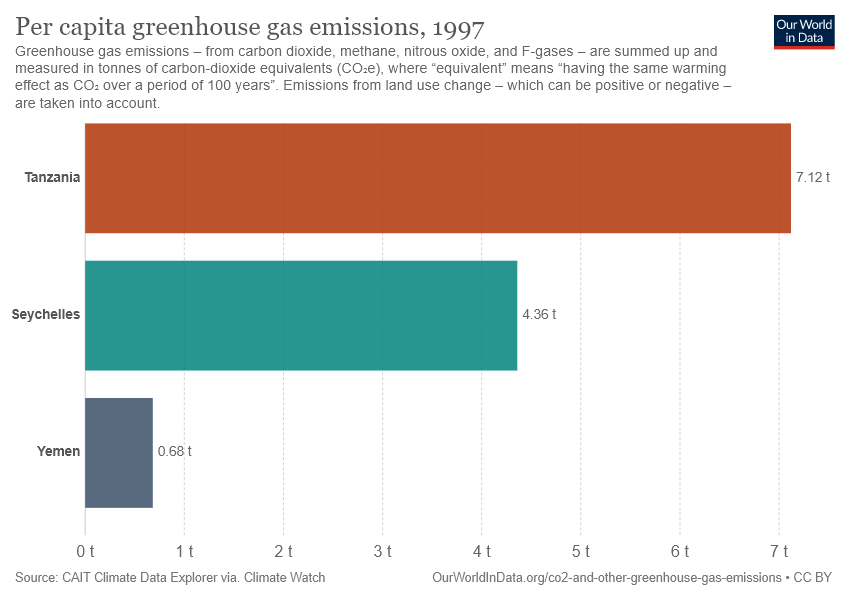Give some essential details in this illustration. The name of the first uppermost bar is Tanzania. The sum of the smallest two bars is not greater than the value of the largest bar. 